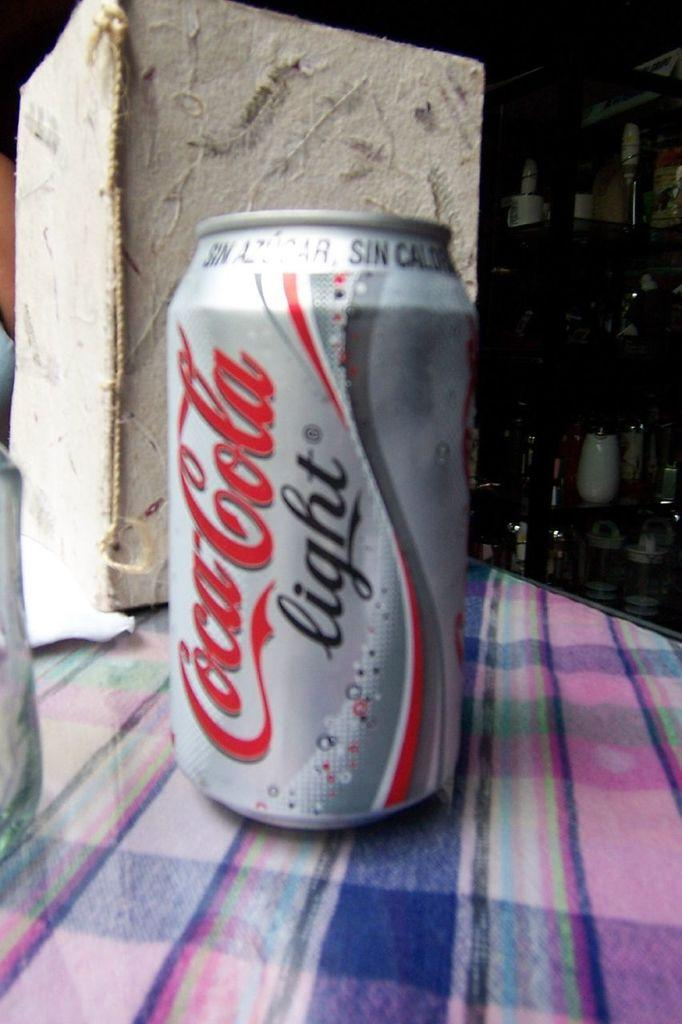<image>
Write a terse but informative summary of the picture. A can of Coca-Cola Light is on a plaid cloth and flat surface. 